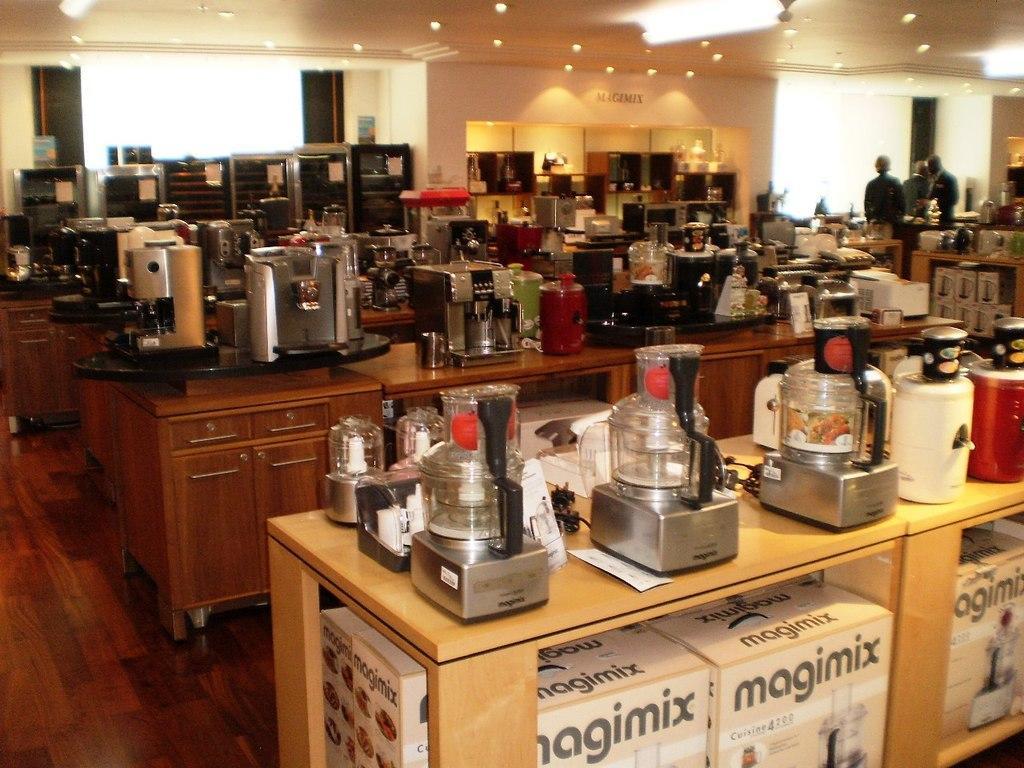In one or two sentences, can you explain what this image depicts? In this image we can see a group of electronic gadgets on the tables. Behind the gadgets we can see a wall. On the top right, we can see persons. At the top we can see the roof and lights. 